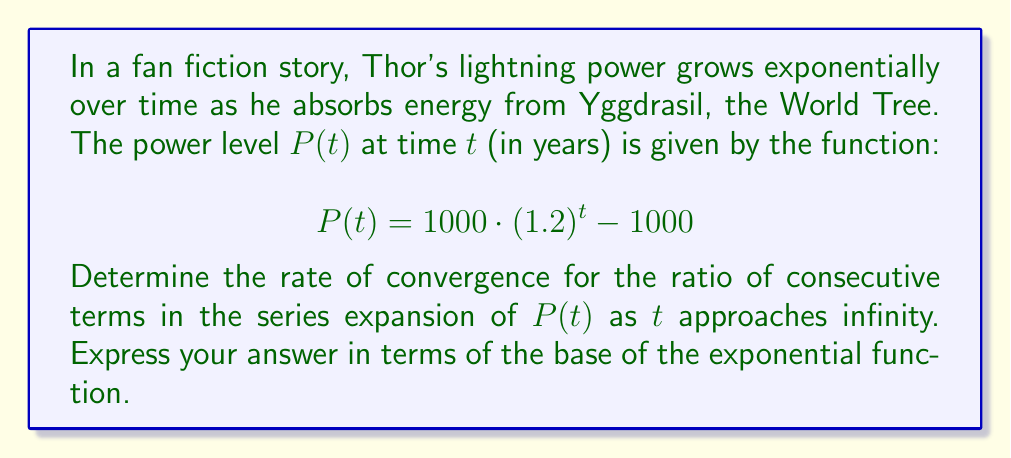Could you help me with this problem? To determine the rate of convergence, we need to follow these steps:

1) First, let's expand $P(t)$ into a series:

   $$P(t) = 1000 \cdot (1.2)^t - 1000$$
   $$= 1000 \cdot (1 + 0.2)^t - 1000$$
   $$= 1000 \cdot \left(1 + \binom{t}{1}0.2 + \binom{t}{2}0.2^2 + \binom{t}{3}0.2^3 + ...\right) - 1000$$
   $$= 1000 \cdot 0.2t + 1000 \cdot \binom{t}{2}0.2^2 + 1000 \cdot \binom{t}{3}0.2^3 + ...$$

2) Let's denote the $n$-th term of this series as $a_n$. Then:

   $$a_n = 1000 \cdot \binom{t}{n}0.2^n$$

3) To find the rate of convergence, we need to calculate the limit of the ratio of consecutive terms as $n$ approaches infinity:

   $$\lim_{n \to \infty} \frac{a_{n+1}}{a_n} = \lim_{n \to \infty} \frac{1000 \cdot \binom{t}{n+1}0.2^{n+1}}{1000 \cdot \binom{t}{n}0.2^n}$$

4) Simplify:

   $$= \lim_{n \to \infty} \frac{\binom{t}{n+1}}{\binom{t}{n}} \cdot 0.2$$

5) We know that $\lim_{n \to \infty} \frac{\binom{t}{n+1}}{\binom{t}{n}} = 1$, so:

   $$= 1 \cdot 0.2 = 0.2$$

6) The rate of convergence is the absolute value of this limit, which is 0.2.

7) 0.2 is the reciprocal of the base of the exponential function (1.2) in the original power function.
Answer: The rate of convergence is 0.2, which is equal to $\frac{1}{b}$, where $b = 1.2$ is the base of the exponential function in the original power function. 